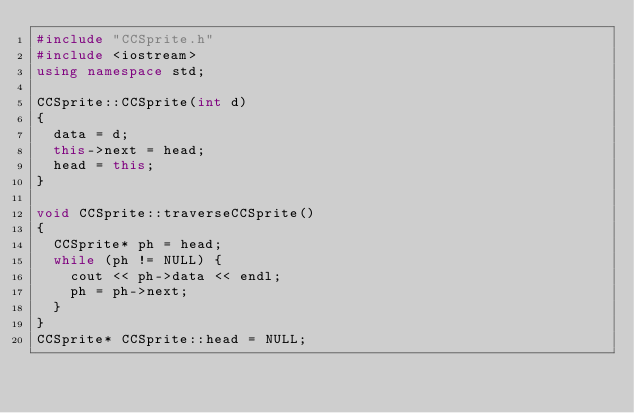Convert code to text. <code><loc_0><loc_0><loc_500><loc_500><_C++_>#include "CCSprite.h"
#include <iostream>
using namespace std;

CCSprite::CCSprite(int d)
{
	data = d;
	this->next = head;
	head = this;
}

void CCSprite::traverseCCSprite()
{
	CCSprite* ph = head;
	while (ph != NULL) {
		cout << ph->data << endl;
		ph = ph->next;
	}
}
CCSprite* CCSprite::head = NULL;

</code> 